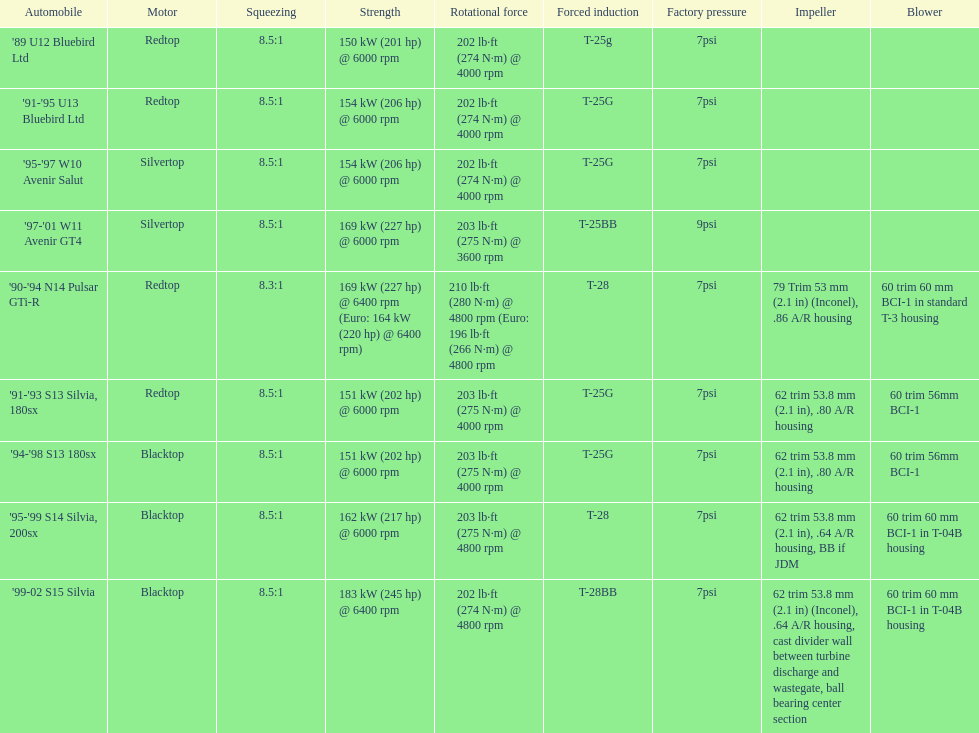Which car is the only one with more than 230 hp? '99-02 S15 Silvia. 